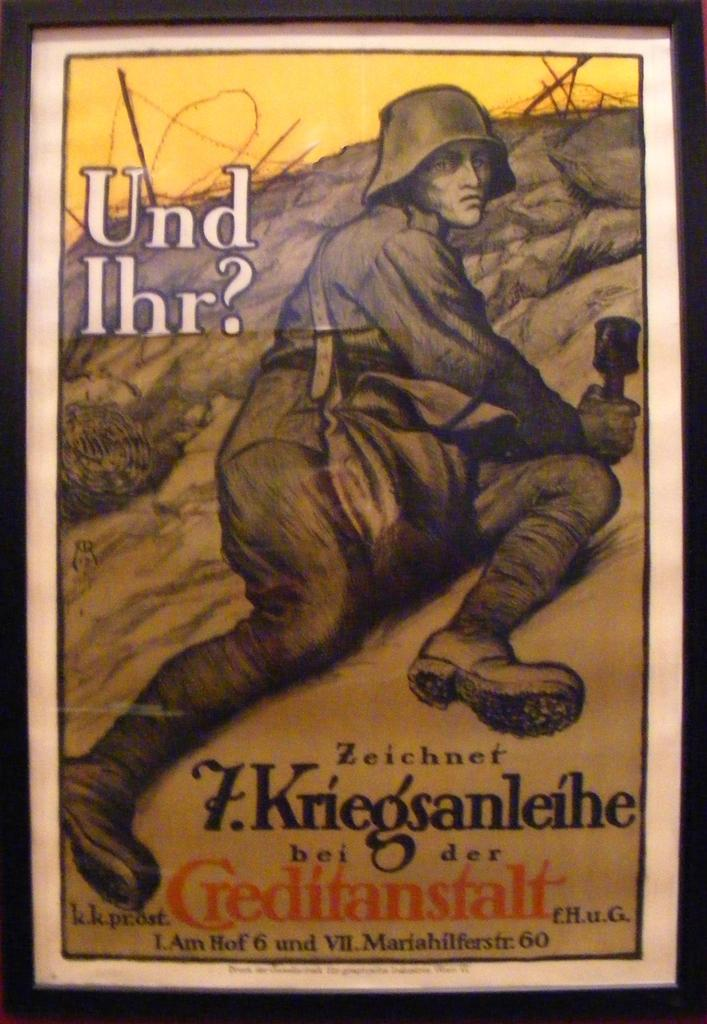<image>
Present a compact description of the photo's key features. A framed piece of art depicts a man on a hill and the title Und Ihr. 